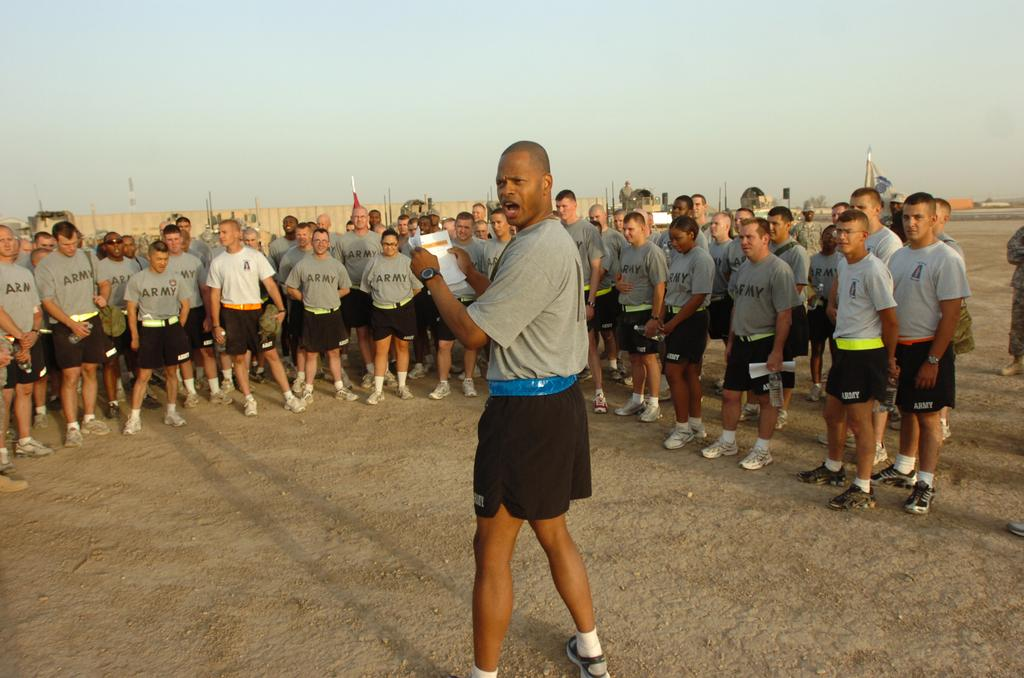What is the main subject of the image? The main subject of the image is men standing. Can you describe the surface on which the men are standing? The men are standing on the ground. What can be seen in the background of the image? There is a sky visible in the background of the image. What type of quiet motion can be observed in the image? There is no quiet motion present in the image, as the men are standing still. Can you see a hose in the image? There is no hose present in the image. 